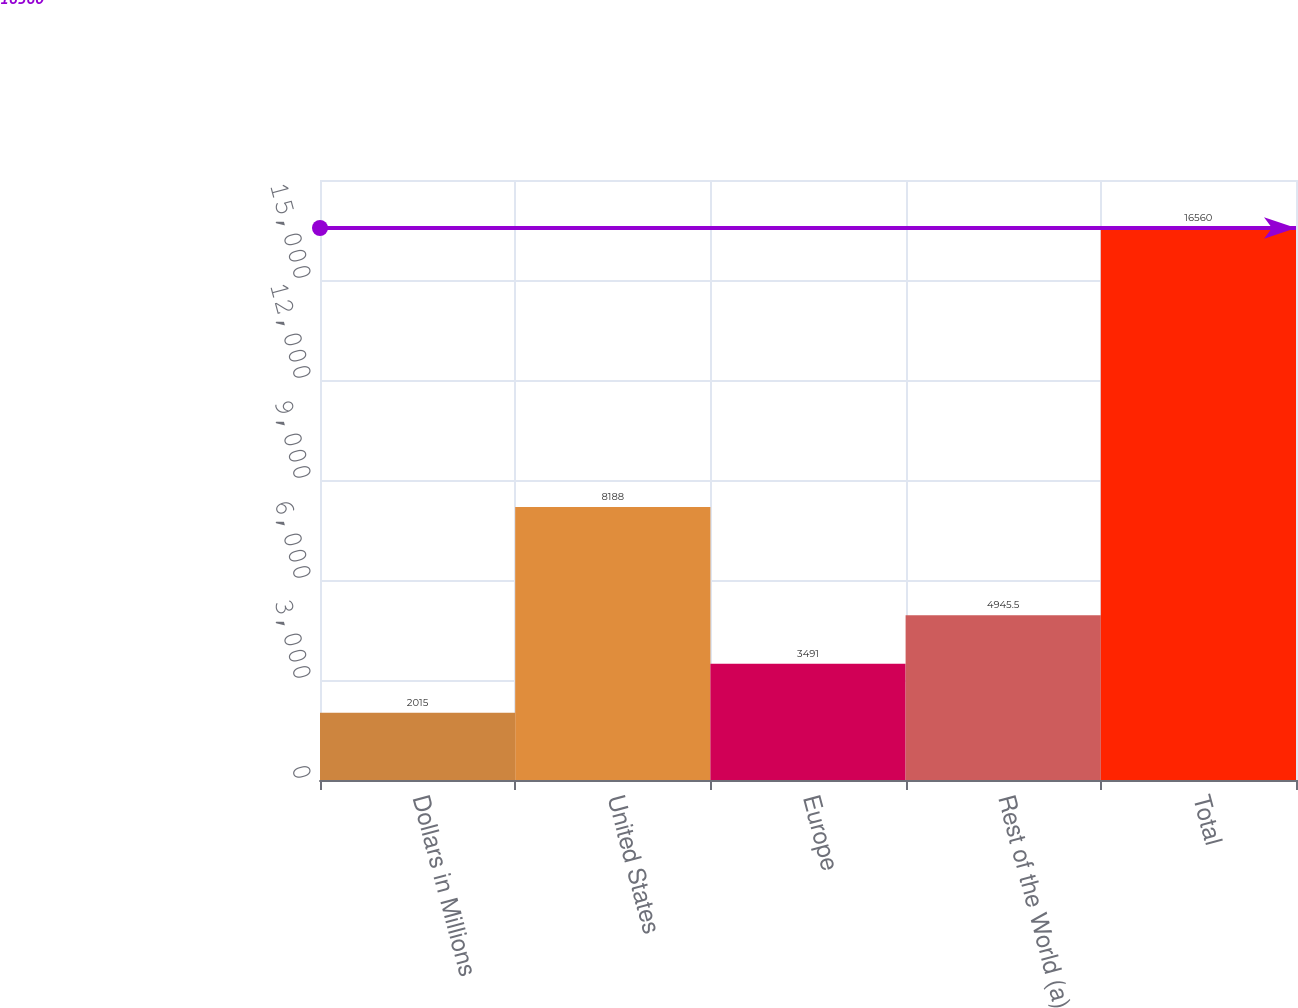Convert chart to OTSL. <chart><loc_0><loc_0><loc_500><loc_500><bar_chart><fcel>Dollars in Millions<fcel>United States<fcel>Europe<fcel>Rest of the World (a)<fcel>Total<nl><fcel>2015<fcel>8188<fcel>3491<fcel>4945.5<fcel>16560<nl></chart> 